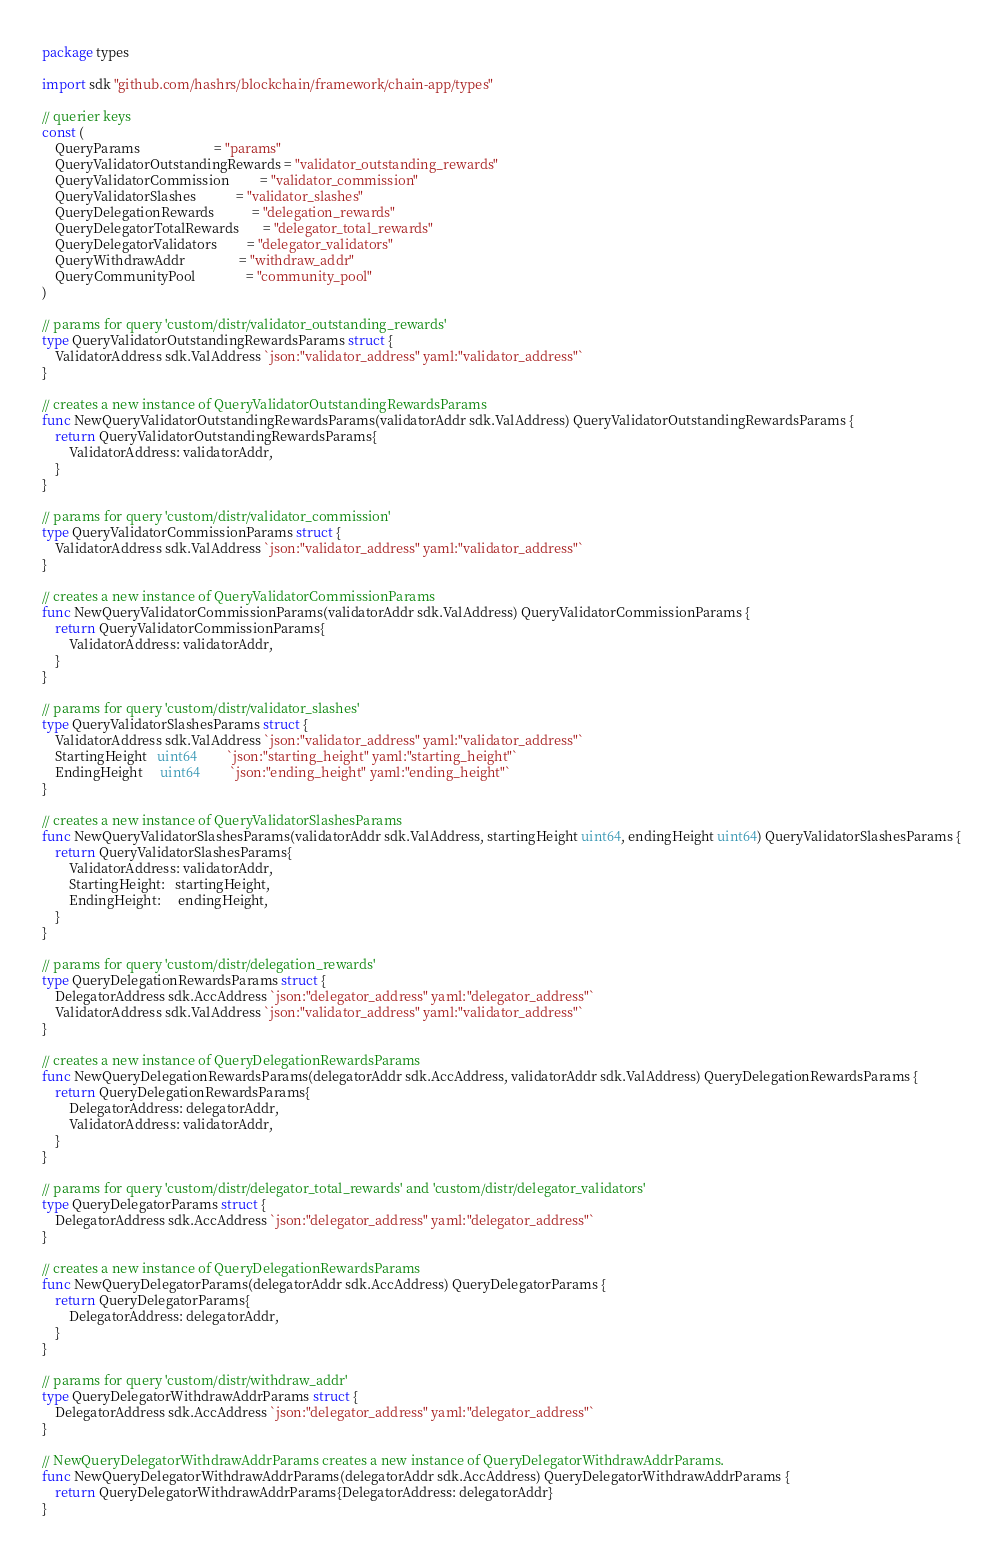Convert code to text. <code><loc_0><loc_0><loc_500><loc_500><_Go_>package types

import sdk "github.com/hashrs/blockchain/framework/chain-app/types"

// querier keys
const (
	QueryParams                      = "params"
	QueryValidatorOutstandingRewards = "validator_outstanding_rewards"
	QueryValidatorCommission         = "validator_commission"
	QueryValidatorSlashes            = "validator_slashes"
	QueryDelegationRewards           = "delegation_rewards"
	QueryDelegatorTotalRewards       = "delegator_total_rewards"
	QueryDelegatorValidators         = "delegator_validators"
	QueryWithdrawAddr                = "withdraw_addr"
	QueryCommunityPool               = "community_pool"
)

// params for query 'custom/distr/validator_outstanding_rewards'
type QueryValidatorOutstandingRewardsParams struct {
	ValidatorAddress sdk.ValAddress `json:"validator_address" yaml:"validator_address"`
}

// creates a new instance of QueryValidatorOutstandingRewardsParams
func NewQueryValidatorOutstandingRewardsParams(validatorAddr sdk.ValAddress) QueryValidatorOutstandingRewardsParams {
	return QueryValidatorOutstandingRewardsParams{
		ValidatorAddress: validatorAddr,
	}
}

// params for query 'custom/distr/validator_commission'
type QueryValidatorCommissionParams struct {
	ValidatorAddress sdk.ValAddress `json:"validator_address" yaml:"validator_address"`
}

// creates a new instance of QueryValidatorCommissionParams
func NewQueryValidatorCommissionParams(validatorAddr sdk.ValAddress) QueryValidatorCommissionParams {
	return QueryValidatorCommissionParams{
		ValidatorAddress: validatorAddr,
	}
}

// params for query 'custom/distr/validator_slashes'
type QueryValidatorSlashesParams struct {
	ValidatorAddress sdk.ValAddress `json:"validator_address" yaml:"validator_address"`
	StartingHeight   uint64         `json:"starting_height" yaml:"starting_height"`
	EndingHeight     uint64         `json:"ending_height" yaml:"ending_height"`
}

// creates a new instance of QueryValidatorSlashesParams
func NewQueryValidatorSlashesParams(validatorAddr sdk.ValAddress, startingHeight uint64, endingHeight uint64) QueryValidatorSlashesParams {
	return QueryValidatorSlashesParams{
		ValidatorAddress: validatorAddr,
		StartingHeight:   startingHeight,
		EndingHeight:     endingHeight,
	}
}

// params for query 'custom/distr/delegation_rewards'
type QueryDelegationRewardsParams struct {
	DelegatorAddress sdk.AccAddress `json:"delegator_address" yaml:"delegator_address"`
	ValidatorAddress sdk.ValAddress `json:"validator_address" yaml:"validator_address"`
}

// creates a new instance of QueryDelegationRewardsParams
func NewQueryDelegationRewardsParams(delegatorAddr sdk.AccAddress, validatorAddr sdk.ValAddress) QueryDelegationRewardsParams {
	return QueryDelegationRewardsParams{
		DelegatorAddress: delegatorAddr,
		ValidatorAddress: validatorAddr,
	}
}

// params for query 'custom/distr/delegator_total_rewards' and 'custom/distr/delegator_validators'
type QueryDelegatorParams struct {
	DelegatorAddress sdk.AccAddress `json:"delegator_address" yaml:"delegator_address"`
}

// creates a new instance of QueryDelegationRewardsParams
func NewQueryDelegatorParams(delegatorAddr sdk.AccAddress) QueryDelegatorParams {
	return QueryDelegatorParams{
		DelegatorAddress: delegatorAddr,
	}
}

// params for query 'custom/distr/withdraw_addr'
type QueryDelegatorWithdrawAddrParams struct {
	DelegatorAddress sdk.AccAddress `json:"delegator_address" yaml:"delegator_address"`
}

// NewQueryDelegatorWithdrawAddrParams creates a new instance of QueryDelegatorWithdrawAddrParams.
func NewQueryDelegatorWithdrawAddrParams(delegatorAddr sdk.AccAddress) QueryDelegatorWithdrawAddrParams {
	return QueryDelegatorWithdrawAddrParams{DelegatorAddress: delegatorAddr}
}
</code> 